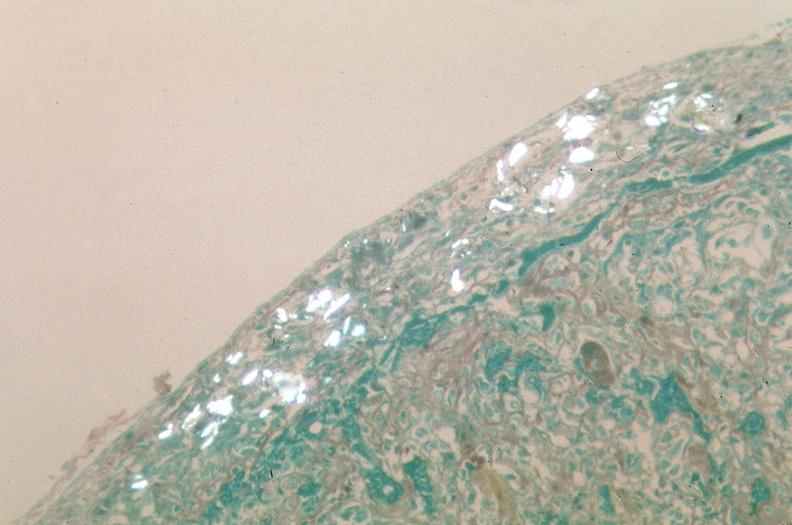was ulcer with candida infection used to sclerose emphysematous lung, alpha-1 antitrypsin deficiency?
Answer the question using a single word or phrase. No 